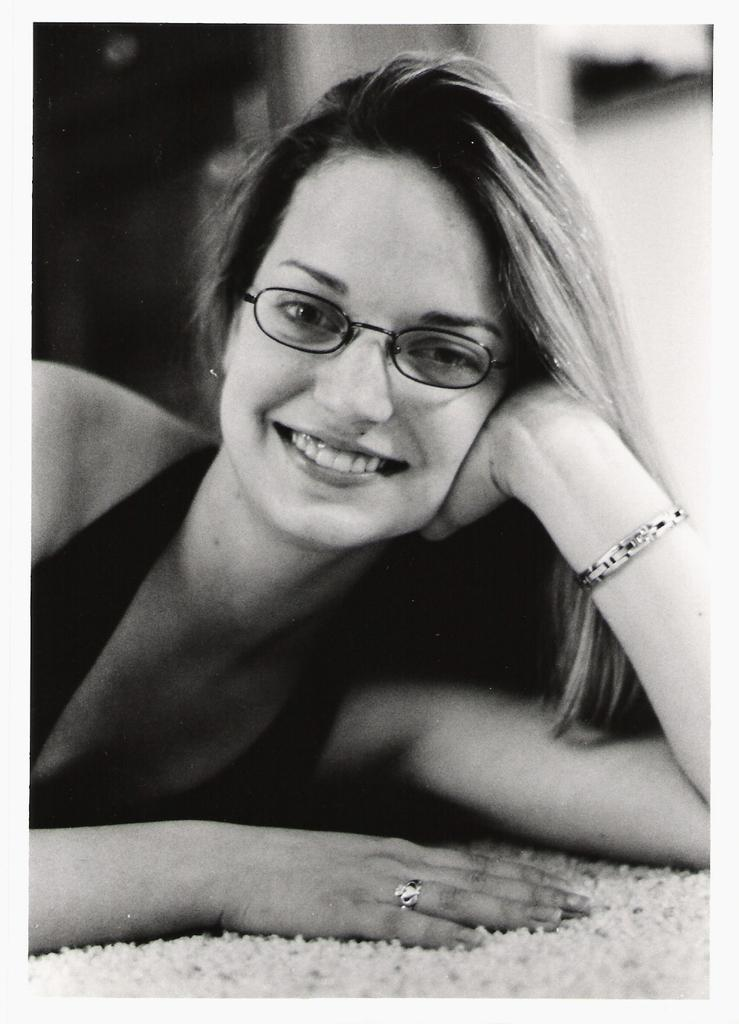What is the position of the person in the image? The person is laying on the floor in the image. What is the color scheme of the image? The image is in black and white. What type of ornament is hanging from the ceiling in the image? There is no ornament hanging from the ceiling in the image, as it is in black and white and only shows a person laying on the floor. 